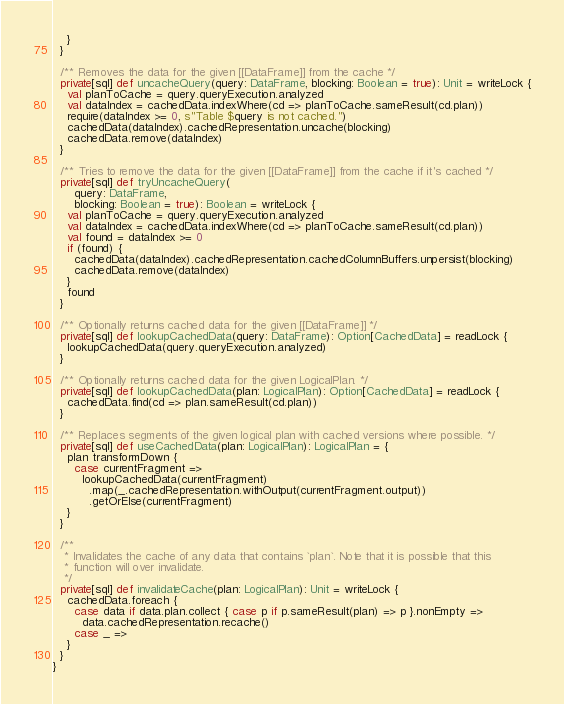Convert code to text. <code><loc_0><loc_0><loc_500><loc_500><_Scala_>    }
  }

  /** Removes the data for the given [[DataFrame]] from the cache */
  private[sql] def uncacheQuery(query: DataFrame, blocking: Boolean = true): Unit = writeLock {
    val planToCache = query.queryExecution.analyzed
    val dataIndex = cachedData.indexWhere(cd => planToCache.sameResult(cd.plan))
    require(dataIndex >= 0, s"Table $query is not cached.")
    cachedData(dataIndex).cachedRepresentation.uncache(blocking)
    cachedData.remove(dataIndex)
  }

  /** Tries to remove the data for the given [[DataFrame]] from the cache if it's cached */
  private[sql] def tryUncacheQuery(
      query: DataFrame,
      blocking: Boolean = true): Boolean = writeLock {
    val planToCache = query.queryExecution.analyzed
    val dataIndex = cachedData.indexWhere(cd => planToCache.sameResult(cd.plan))
    val found = dataIndex >= 0
    if (found) {
      cachedData(dataIndex).cachedRepresentation.cachedColumnBuffers.unpersist(blocking)
      cachedData.remove(dataIndex)
    }
    found
  }

  /** Optionally returns cached data for the given [[DataFrame]] */
  private[sql] def lookupCachedData(query: DataFrame): Option[CachedData] = readLock {
    lookupCachedData(query.queryExecution.analyzed)
  }

  /** Optionally returns cached data for the given LogicalPlan. */
  private[sql] def lookupCachedData(plan: LogicalPlan): Option[CachedData] = readLock {
    cachedData.find(cd => plan.sameResult(cd.plan))
  }

  /** Replaces segments of the given logical plan with cached versions where possible. */
  private[sql] def useCachedData(plan: LogicalPlan): LogicalPlan = {
    plan transformDown {
      case currentFragment =>
        lookupCachedData(currentFragment)
          .map(_.cachedRepresentation.withOutput(currentFragment.output))
          .getOrElse(currentFragment)
    }
  }

  /**
   * Invalidates the cache of any data that contains `plan`. Note that it is possible that this
   * function will over invalidate.
   */
  private[sql] def invalidateCache(plan: LogicalPlan): Unit = writeLock {
    cachedData.foreach {
      case data if data.plan.collect { case p if p.sameResult(plan) => p }.nonEmpty =>
        data.cachedRepresentation.recache()
      case _ =>
    }
  }
}
</code> 